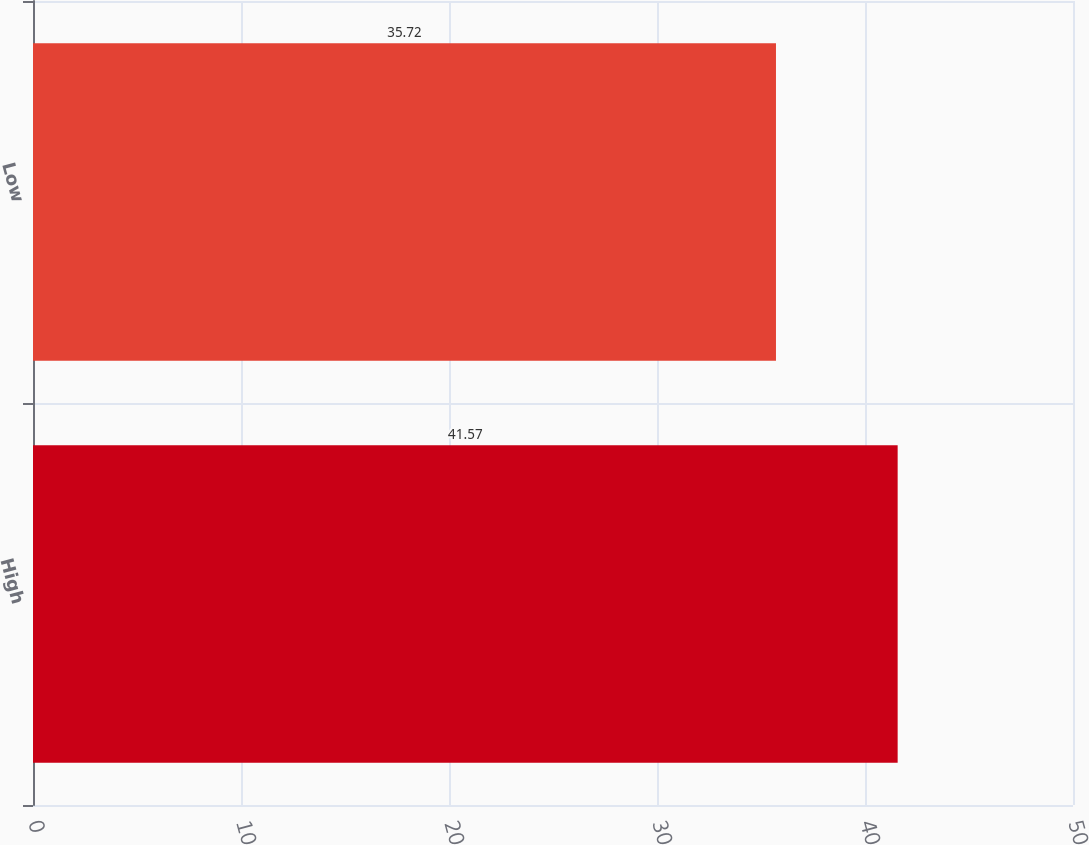Convert chart. <chart><loc_0><loc_0><loc_500><loc_500><bar_chart><fcel>High<fcel>Low<nl><fcel>41.57<fcel>35.72<nl></chart> 